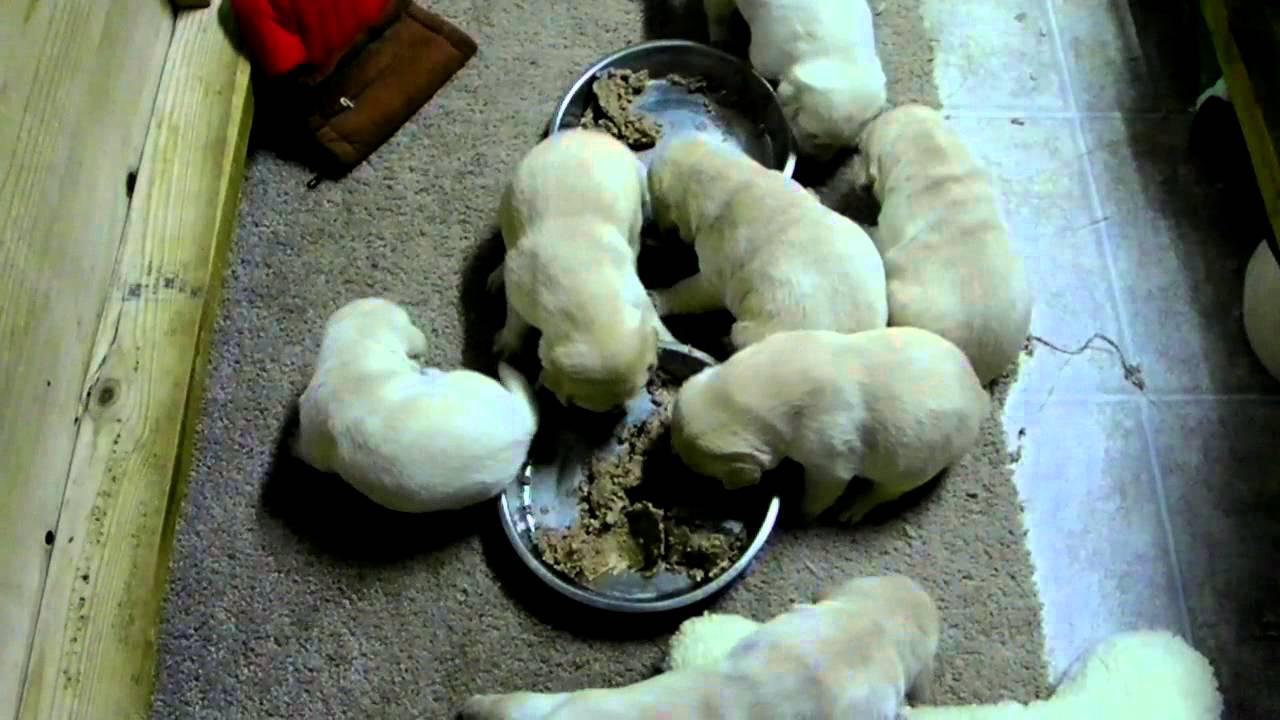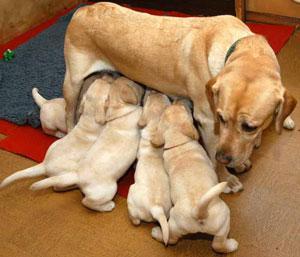The first image is the image on the left, the second image is the image on the right. For the images displayed, is the sentence "There are no more than four dogs." factually correct? Answer yes or no. No. The first image is the image on the left, the second image is the image on the right. Examine the images to the left and right. Is the description "No more than 3 puppies are eating food from a bowl." accurate? Answer yes or no. No. 